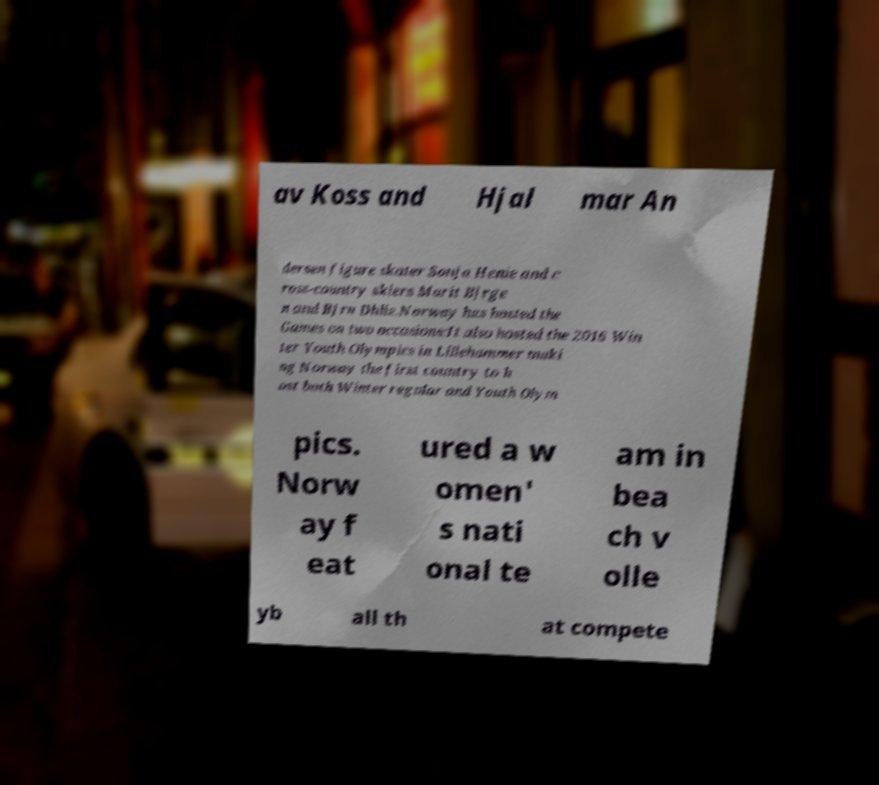There's text embedded in this image that I need extracted. Can you transcribe it verbatim? av Koss and Hjal mar An dersen figure skater Sonja Henie and c ross-country skiers Marit Bjrge n and Bjrn Dhlie.Norway has hosted the Games on two occasions:It also hosted the 2016 Win ter Youth Olympics in Lillehammer maki ng Norway the first country to h ost both Winter regular and Youth Olym pics. Norw ay f eat ured a w omen' s nati onal te am in bea ch v olle yb all th at compete 